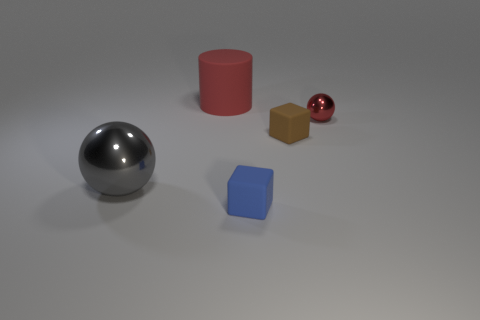Add 1 large blue shiny cylinders. How many objects exist? 6 Subtract 2 blocks. How many blocks are left? 0 Subtract all purple cubes. Subtract all green cylinders. How many cubes are left? 2 Subtract all tiny brown cubes. Subtract all tiny red metallic spheres. How many objects are left? 3 Add 3 gray metal balls. How many gray metal balls are left? 4 Add 3 red things. How many red things exist? 5 Subtract all blue cubes. How many cubes are left? 1 Subtract 0 purple cubes. How many objects are left? 5 Subtract all cylinders. How many objects are left? 4 